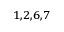<formula> <loc_0><loc_0><loc_500><loc_500>^ { 1 , 2 , 6 , 7 }</formula> 